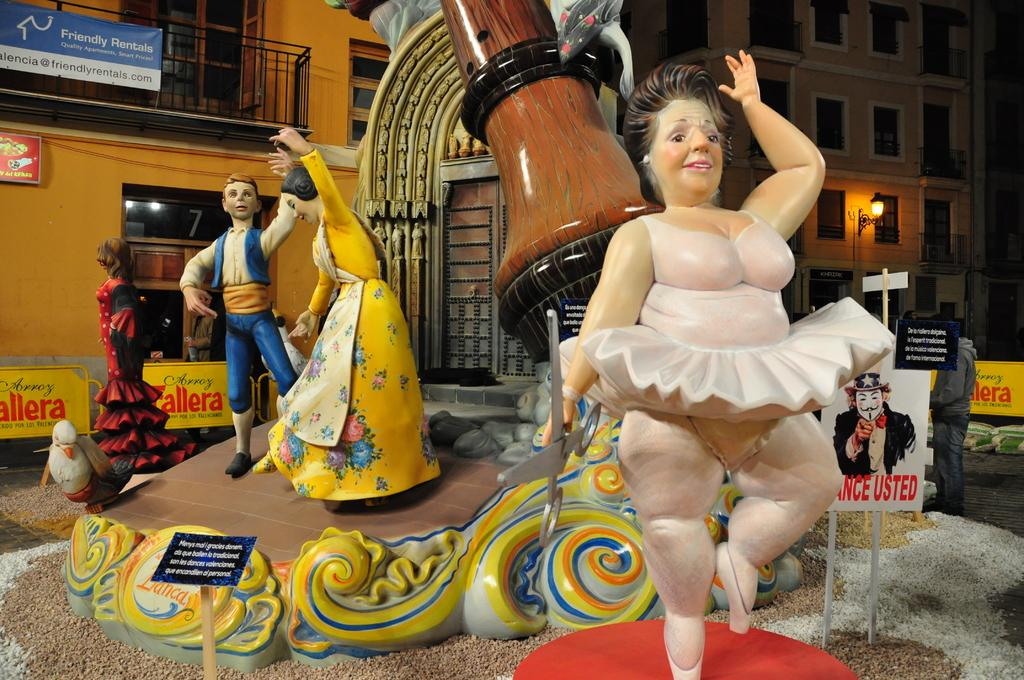What objects are in the foreground of the image? There are toys in the foreground of the image. Where is the person located in the image? The person is on the right side of the image. What can be seen in the background of the image? There are buildings in the background of the image. How many pizzas are being held by the person in the image? There are no pizzas present in the image; the person is not holding any. What type of selection is available at the toy store in the image? There is no toy store mentioned in the image, so it is not possible to determine the selection available. 